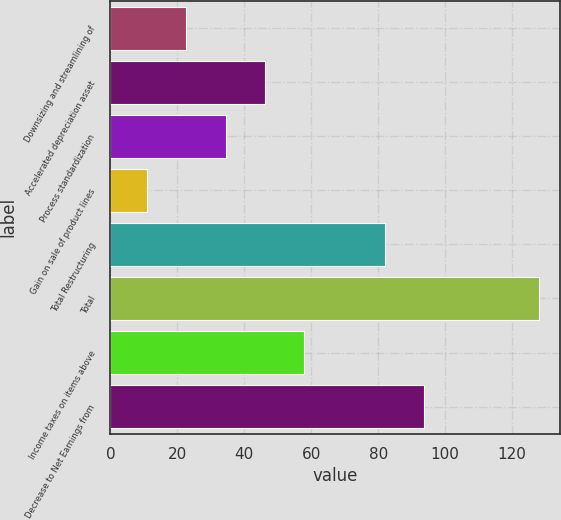Convert chart to OTSL. <chart><loc_0><loc_0><loc_500><loc_500><bar_chart><fcel>Downsizing and streamlining of<fcel>Accelerated depreciation asset<fcel>Process standardization<fcel>Gain on sale of product lines<fcel>Total Restructuring<fcel>Total<fcel>Income taxes on items above<fcel>Decrease to Net Earnings from<nl><fcel>22.7<fcel>46.1<fcel>34.4<fcel>11<fcel>82<fcel>128<fcel>57.8<fcel>93.7<nl></chart> 